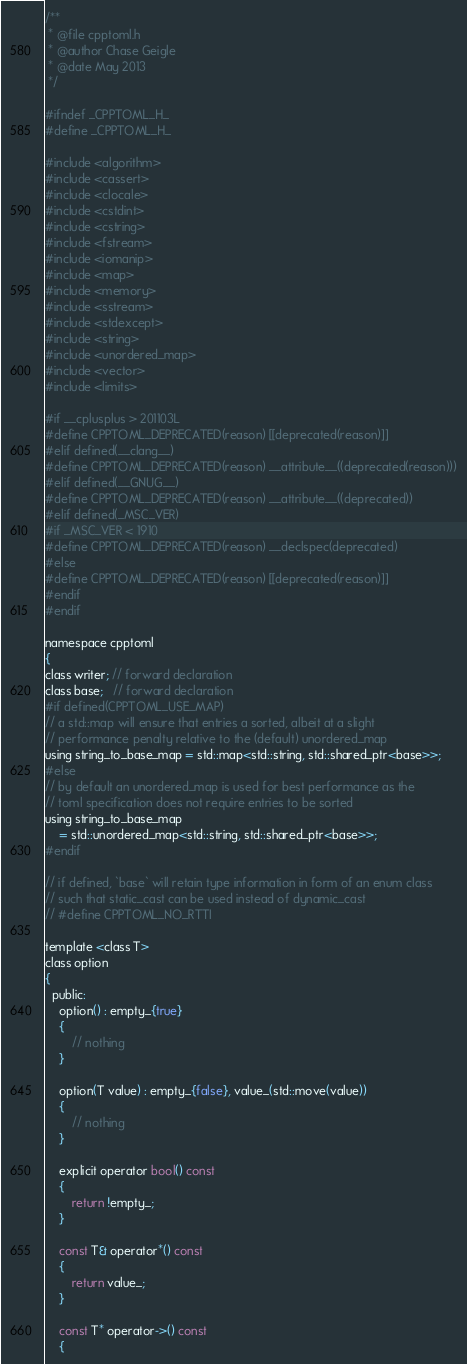Convert code to text. <code><loc_0><loc_0><loc_500><loc_500><_C_>/**
 * @file cpptoml.h
 * @author Chase Geigle
 * @date May 2013
 */

#ifndef _CPPTOML_H_
#define _CPPTOML_H_

#include <algorithm>
#include <cassert>
#include <clocale>
#include <cstdint>
#include <cstring>
#include <fstream>
#include <iomanip>
#include <map>
#include <memory>
#include <sstream>
#include <stdexcept>
#include <string>
#include <unordered_map>
#include <vector>
#include <limits>

#if __cplusplus > 201103L
#define CPPTOML_DEPRECATED(reason) [[deprecated(reason)]]
#elif defined(__clang__)
#define CPPTOML_DEPRECATED(reason) __attribute__((deprecated(reason)))
#elif defined(__GNUG__)
#define CPPTOML_DEPRECATED(reason) __attribute__((deprecated))
#elif defined(_MSC_VER)
#if _MSC_VER < 1910
#define CPPTOML_DEPRECATED(reason) __declspec(deprecated)
#else
#define CPPTOML_DEPRECATED(reason) [[deprecated(reason)]]
#endif
#endif

namespace cpptoml
{
class writer; // forward declaration
class base;   // forward declaration
#if defined(CPPTOML_USE_MAP)
// a std::map will ensure that entries a sorted, albeit at a slight
// performance penalty relative to the (default) unordered_map
using string_to_base_map = std::map<std::string, std::shared_ptr<base>>;
#else
// by default an unordered_map is used for best performance as the
// toml specification does not require entries to be sorted
using string_to_base_map
    = std::unordered_map<std::string, std::shared_ptr<base>>;
#endif

// if defined, `base` will retain type information in form of an enum class
// such that static_cast can be used instead of dynamic_cast
// #define CPPTOML_NO_RTTI

template <class T>
class option
{
  public:
    option() : empty_{true}
    {
        // nothing
    }

    option(T value) : empty_{false}, value_(std::move(value))
    {
        // nothing
    }

    explicit operator bool() const
    {
        return !empty_;
    }

    const T& operator*() const
    {
        return value_;
    }

    const T* operator->() const
    {</code> 